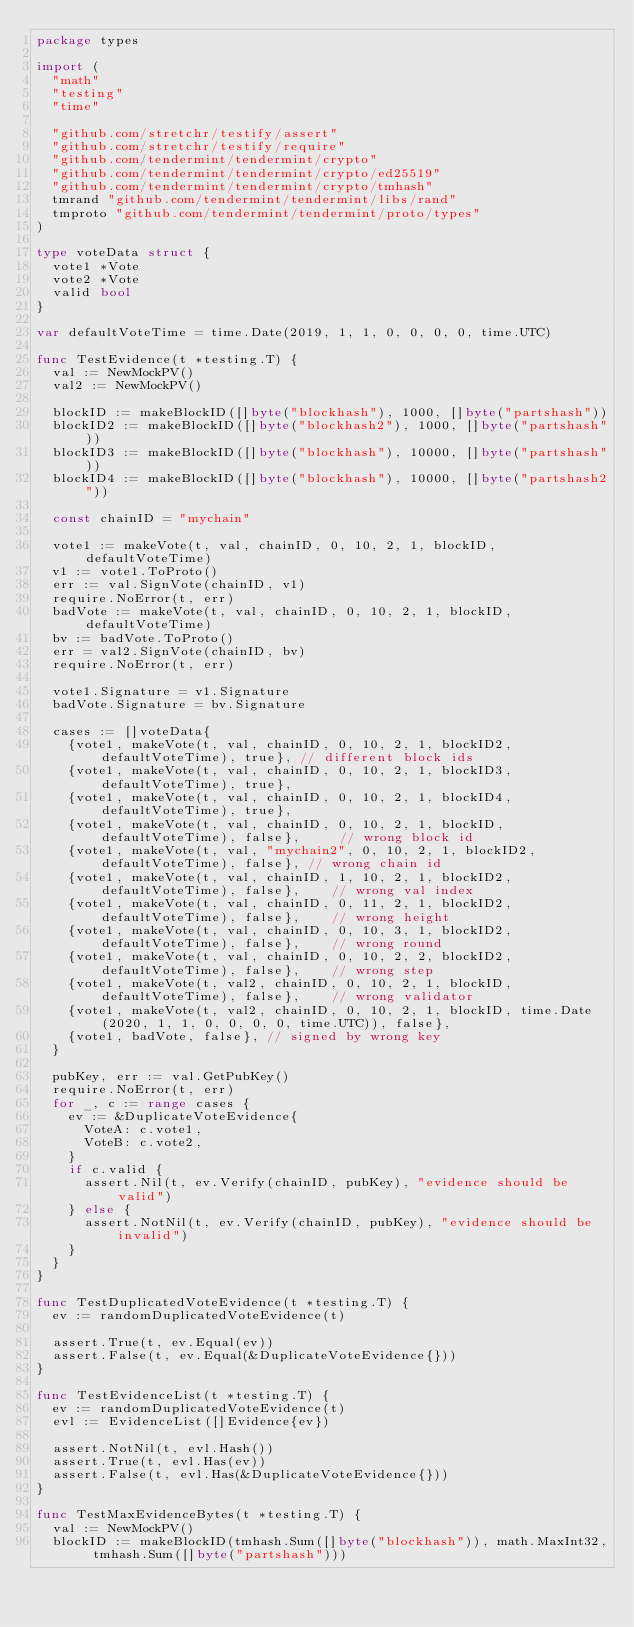Convert code to text. <code><loc_0><loc_0><loc_500><loc_500><_Go_>package types

import (
	"math"
	"testing"
	"time"

	"github.com/stretchr/testify/assert"
	"github.com/stretchr/testify/require"
	"github.com/tendermint/tendermint/crypto"
	"github.com/tendermint/tendermint/crypto/ed25519"
	"github.com/tendermint/tendermint/crypto/tmhash"
	tmrand "github.com/tendermint/tendermint/libs/rand"
	tmproto "github.com/tendermint/tendermint/proto/types"
)

type voteData struct {
	vote1 *Vote
	vote2 *Vote
	valid bool
}

var defaultVoteTime = time.Date(2019, 1, 1, 0, 0, 0, 0, time.UTC)

func TestEvidence(t *testing.T) {
	val := NewMockPV()
	val2 := NewMockPV()

	blockID := makeBlockID([]byte("blockhash"), 1000, []byte("partshash"))
	blockID2 := makeBlockID([]byte("blockhash2"), 1000, []byte("partshash"))
	blockID3 := makeBlockID([]byte("blockhash"), 10000, []byte("partshash"))
	blockID4 := makeBlockID([]byte("blockhash"), 10000, []byte("partshash2"))

	const chainID = "mychain"

	vote1 := makeVote(t, val, chainID, 0, 10, 2, 1, blockID, defaultVoteTime)
	v1 := vote1.ToProto()
	err := val.SignVote(chainID, v1)
	require.NoError(t, err)
	badVote := makeVote(t, val, chainID, 0, 10, 2, 1, blockID, defaultVoteTime)
	bv := badVote.ToProto()
	err = val2.SignVote(chainID, bv)
	require.NoError(t, err)

	vote1.Signature = v1.Signature
	badVote.Signature = bv.Signature

	cases := []voteData{
		{vote1, makeVote(t, val, chainID, 0, 10, 2, 1, blockID2, defaultVoteTime), true}, // different block ids
		{vote1, makeVote(t, val, chainID, 0, 10, 2, 1, blockID3, defaultVoteTime), true},
		{vote1, makeVote(t, val, chainID, 0, 10, 2, 1, blockID4, defaultVoteTime), true},
		{vote1, makeVote(t, val, chainID, 0, 10, 2, 1, blockID, defaultVoteTime), false},     // wrong block id
		{vote1, makeVote(t, val, "mychain2", 0, 10, 2, 1, blockID2, defaultVoteTime), false}, // wrong chain id
		{vote1, makeVote(t, val, chainID, 1, 10, 2, 1, blockID2, defaultVoteTime), false},    // wrong val index
		{vote1, makeVote(t, val, chainID, 0, 11, 2, 1, blockID2, defaultVoteTime), false},    // wrong height
		{vote1, makeVote(t, val, chainID, 0, 10, 3, 1, blockID2, defaultVoteTime), false},    // wrong round
		{vote1, makeVote(t, val, chainID, 0, 10, 2, 2, blockID2, defaultVoteTime), false},    // wrong step
		{vote1, makeVote(t, val2, chainID, 0, 10, 2, 1, blockID, defaultVoteTime), false},    // wrong validator
		{vote1, makeVote(t, val2, chainID, 0, 10, 2, 1, blockID, time.Date(2020, 1, 1, 0, 0, 0, 0, time.UTC)), false},
		{vote1, badVote, false}, // signed by wrong key
	}

	pubKey, err := val.GetPubKey()
	require.NoError(t, err)
	for _, c := range cases {
		ev := &DuplicateVoteEvidence{
			VoteA: c.vote1,
			VoteB: c.vote2,
		}
		if c.valid {
			assert.Nil(t, ev.Verify(chainID, pubKey), "evidence should be valid")
		} else {
			assert.NotNil(t, ev.Verify(chainID, pubKey), "evidence should be invalid")
		}
	}
}

func TestDuplicatedVoteEvidence(t *testing.T) {
	ev := randomDuplicatedVoteEvidence(t)

	assert.True(t, ev.Equal(ev))
	assert.False(t, ev.Equal(&DuplicateVoteEvidence{}))
}

func TestEvidenceList(t *testing.T) {
	ev := randomDuplicatedVoteEvidence(t)
	evl := EvidenceList([]Evidence{ev})

	assert.NotNil(t, evl.Hash())
	assert.True(t, evl.Has(ev))
	assert.False(t, evl.Has(&DuplicateVoteEvidence{}))
}

func TestMaxEvidenceBytes(t *testing.T) {
	val := NewMockPV()
	blockID := makeBlockID(tmhash.Sum([]byte("blockhash")), math.MaxInt32, tmhash.Sum([]byte("partshash")))</code> 